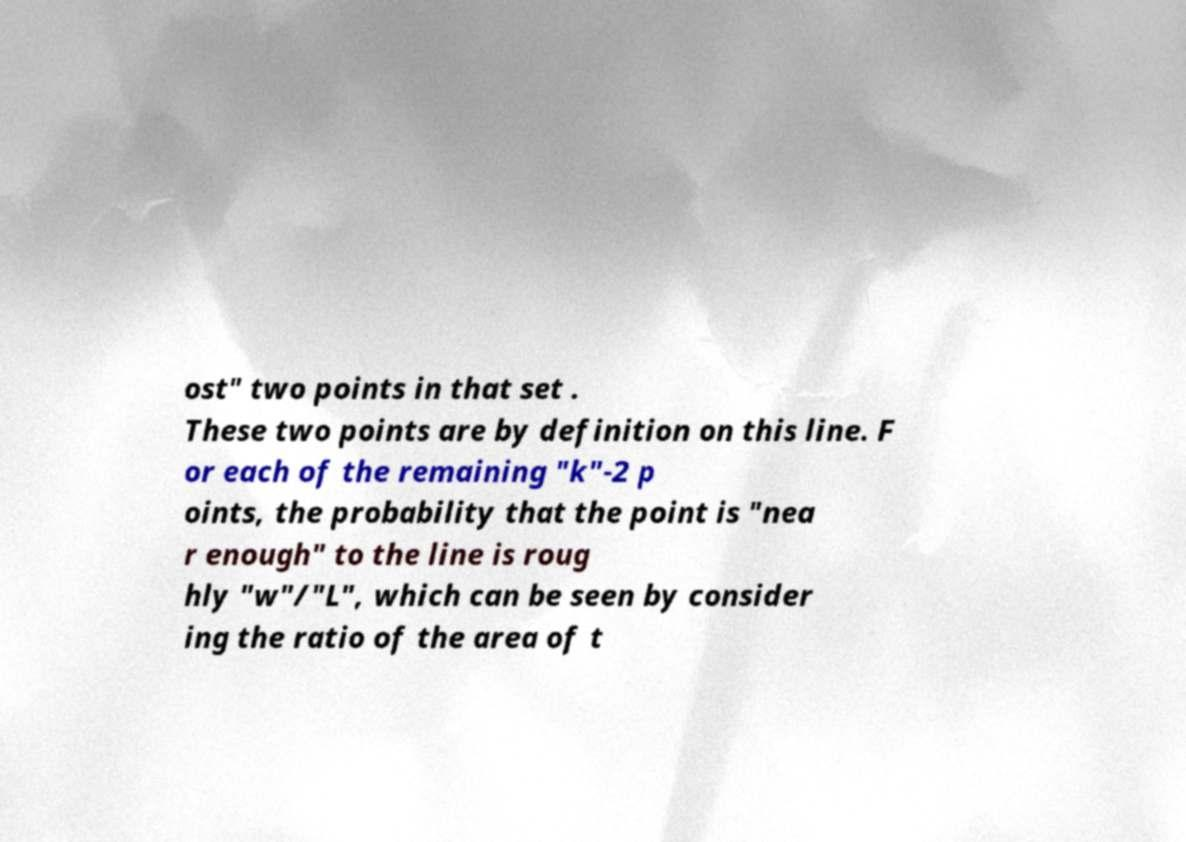Could you assist in decoding the text presented in this image and type it out clearly? ost" two points in that set . These two points are by definition on this line. F or each of the remaining "k"-2 p oints, the probability that the point is "nea r enough" to the line is roug hly "w"/"L", which can be seen by consider ing the ratio of the area of t 